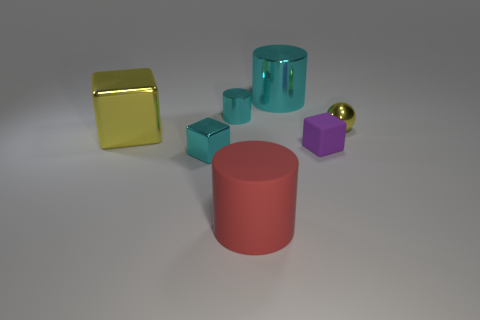Add 1 tiny cyan metal cubes. How many objects exist? 8 Subtract all cylinders. How many objects are left? 4 Subtract 0 yellow cylinders. How many objects are left? 7 Subtract all large red cylinders. Subtract all purple blocks. How many objects are left? 5 Add 2 large cyan objects. How many large cyan objects are left? 3 Add 6 red rubber things. How many red rubber things exist? 7 